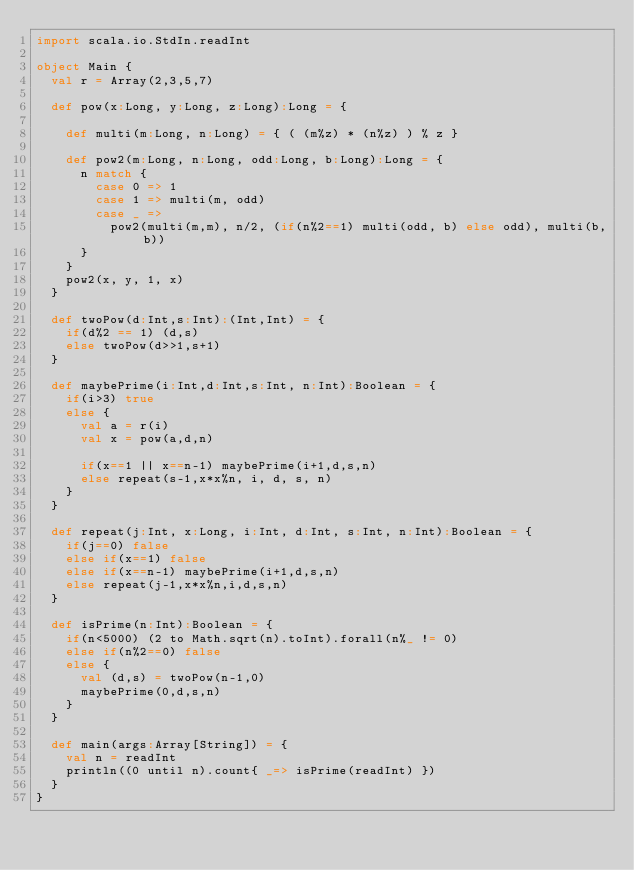Convert code to text. <code><loc_0><loc_0><loc_500><loc_500><_Scala_>import scala.io.StdIn.readInt

object Main {
  val r = Array(2,3,5,7)

  def pow(x:Long, y:Long, z:Long):Long = {

    def multi(m:Long, n:Long) = { ( (m%z) * (n%z) ) % z }

    def pow2(m:Long, n:Long, odd:Long, b:Long):Long = {
      n match {
        case 0 => 1
        case 1 => multi(m, odd)
        case _ =>
          pow2(multi(m,m), n/2, (if(n%2==1) multi(odd, b) else odd), multi(b,b))
      }
    }
    pow2(x, y, 1, x)
  }

  def twoPow(d:Int,s:Int):(Int,Int) = {
    if(d%2 == 1) (d,s)
    else twoPow(d>>1,s+1)
  }

  def maybePrime(i:Int,d:Int,s:Int, n:Int):Boolean = {
    if(i>3) true
    else {
      val a = r(i)
      val x = pow(a,d,n)

      if(x==1 || x==n-1) maybePrime(i+1,d,s,n)
      else repeat(s-1,x*x%n, i, d, s, n)
    }
  }

  def repeat(j:Int, x:Long, i:Int, d:Int, s:Int, n:Int):Boolean = {
    if(j==0) false
    else if(x==1) false
    else if(x==n-1) maybePrime(i+1,d,s,n)
    else repeat(j-1,x*x%n,i,d,s,n)
  }

  def isPrime(n:Int):Boolean = {
    if(n<5000) (2 to Math.sqrt(n).toInt).forall(n%_ != 0)
    else if(n%2==0) false
    else {
      val (d,s) = twoPow(n-1,0)
      maybePrime(0,d,s,n)
    }
  }

  def main(args:Array[String]) = {
    val n = readInt
    println((0 until n).count{ _=> isPrime(readInt) })
  }
}</code> 